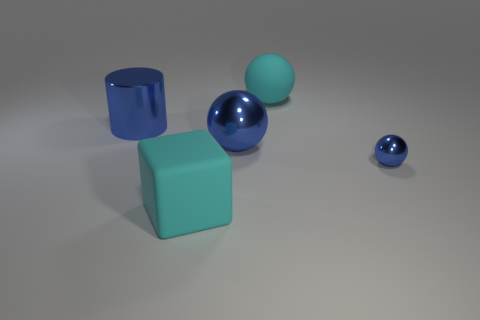There is a big metallic object right of the cyan matte cube; is its color the same as the thing to the right of the big rubber ball?
Your response must be concise. Yes. What size is the other blue shiny thing that is the same shape as the small blue thing?
Your answer should be very brief. Large. Is there another shiny ball of the same color as the small metal sphere?
Your response must be concise. Yes. What material is the tiny ball that is the same color as the large metallic sphere?
Provide a short and direct response. Metal. What number of tiny things are the same color as the big rubber block?
Your answer should be compact. 0. What number of things are spheres that are on the right side of the large cyan matte ball or big cyan rubber blocks?
Your response must be concise. 2. What is the color of the tiny sphere that is the same material as the big blue cylinder?
Provide a succinct answer. Blue. Are there any blue shiny things of the same size as the matte ball?
Your answer should be very brief. Yes. What number of things are objects that are behind the cyan block or big objects behind the small blue object?
Offer a terse response. 4. What shape is the cyan object that is the same size as the cyan block?
Offer a terse response. Sphere. 